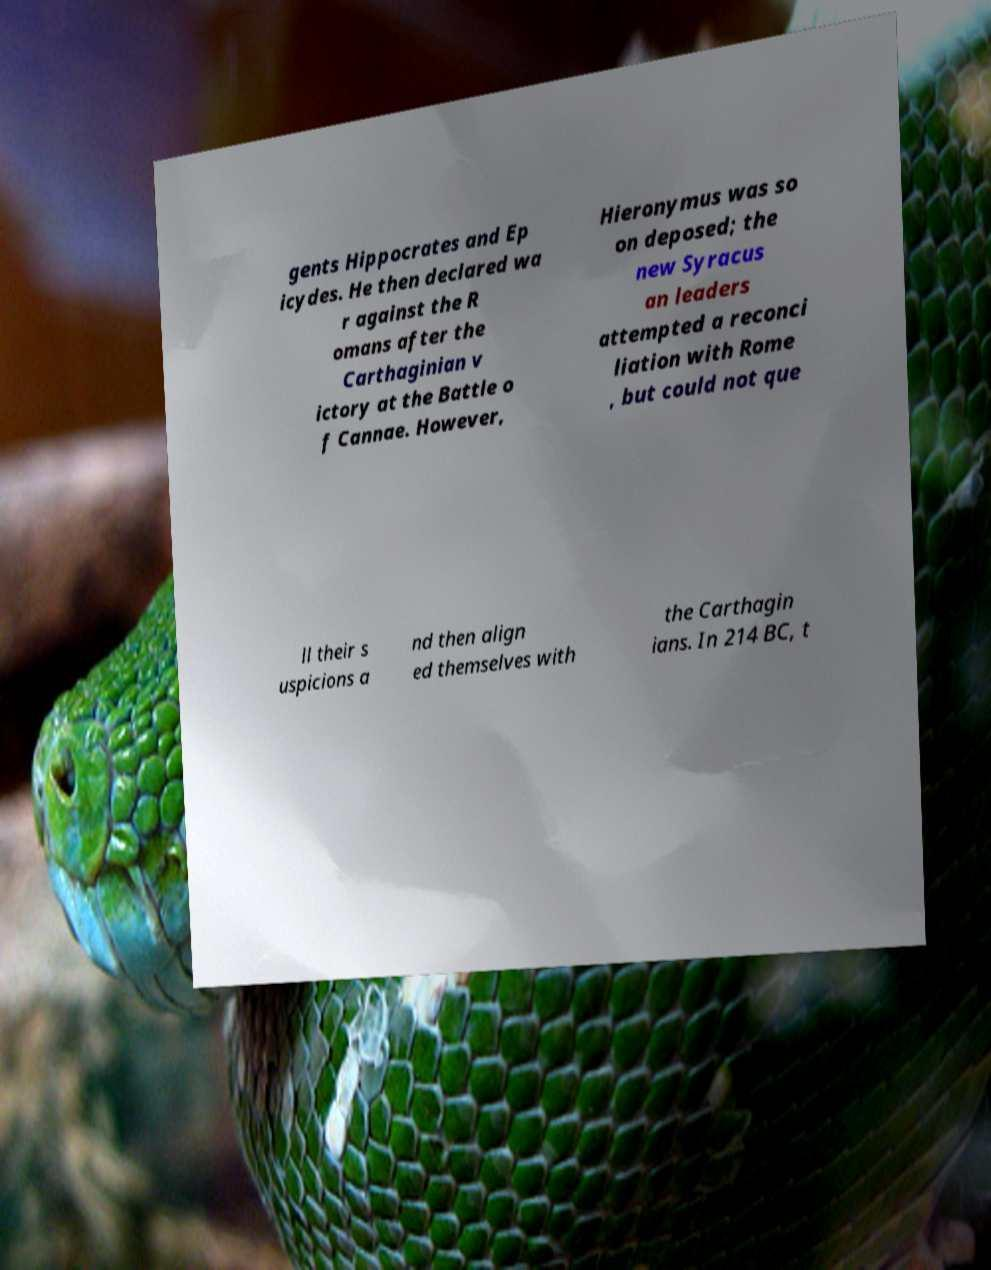What messages or text are displayed in this image? I need them in a readable, typed format. gents Hippocrates and Ep icydes. He then declared wa r against the R omans after the Carthaginian v ictory at the Battle o f Cannae. However, Hieronymus was so on deposed; the new Syracus an leaders attempted a reconci liation with Rome , but could not que ll their s uspicions a nd then align ed themselves with the Carthagin ians. In 214 BC, t 